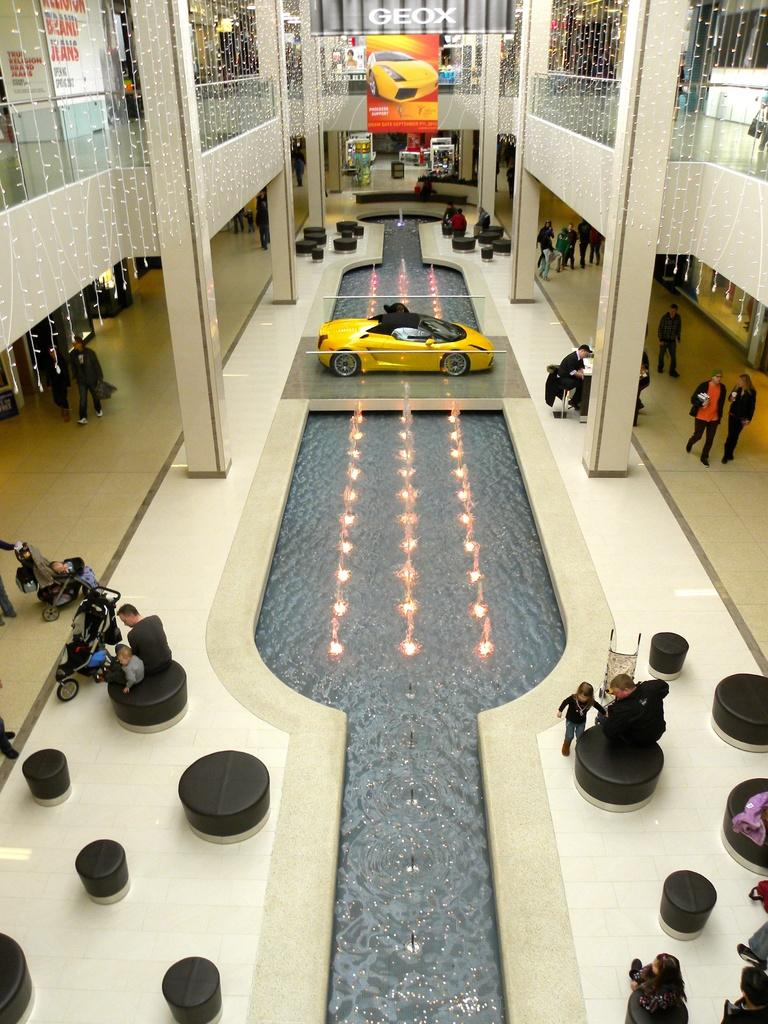What is the main subject of the image? The main subject of the image is a car. What else can be seen in the image besides the car? There is a building, a banner, some people sitting, some people walking, and lights visible in the image. What is the purpose of the banner in the image? The purpose of the banner cannot be determined from the image alone. What are the people in the image doing? Some people are sitting, and some people are walking in the image. What is the price of the butter in the image? There is no butter present in the image, so it is not possible to determine its price. 